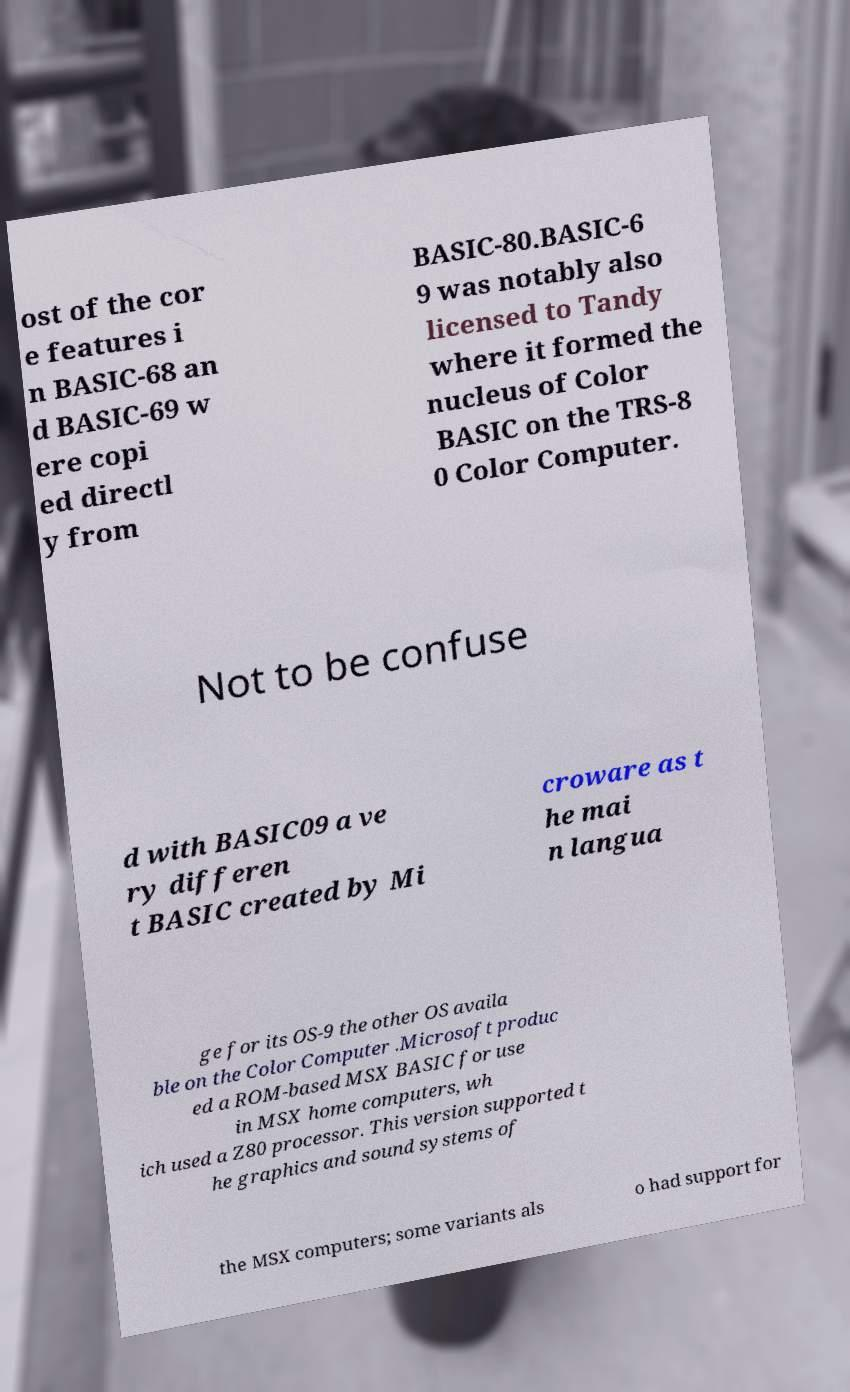What messages or text are displayed in this image? I need them in a readable, typed format. ost of the cor e features i n BASIC-68 an d BASIC-69 w ere copi ed directl y from BASIC-80.BASIC-6 9 was notably also licensed to Tandy where it formed the nucleus of Color BASIC on the TRS-8 0 Color Computer. Not to be confuse d with BASIC09 a ve ry differen t BASIC created by Mi croware as t he mai n langua ge for its OS-9 the other OS availa ble on the Color Computer .Microsoft produc ed a ROM-based MSX BASIC for use in MSX home computers, wh ich used a Z80 processor. This version supported t he graphics and sound systems of the MSX computers; some variants als o had support for 